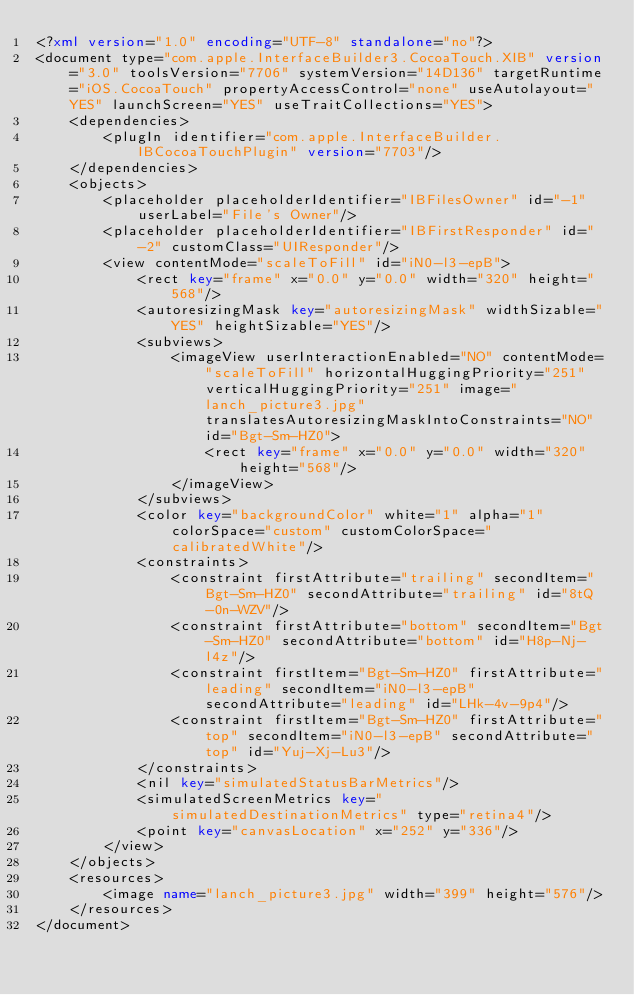<code> <loc_0><loc_0><loc_500><loc_500><_XML_><?xml version="1.0" encoding="UTF-8" standalone="no"?>
<document type="com.apple.InterfaceBuilder3.CocoaTouch.XIB" version="3.0" toolsVersion="7706" systemVersion="14D136" targetRuntime="iOS.CocoaTouch" propertyAccessControl="none" useAutolayout="YES" launchScreen="YES" useTraitCollections="YES">
    <dependencies>
        <plugIn identifier="com.apple.InterfaceBuilder.IBCocoaTouchPlugin" version="7703"/>
    </dependencies>
    <objects>
        <placeholder placeholderIdentifier="IBFilesOwner" id="-1" userLabel="File's Owner"/>
        <placeholder placeholderIdentifier="IBFirstResponder" id="-2" customClass="UIResponder"/>
        <view contentMode="scaleToFill" id="iN0-l3-epB">
            <rect key="frame" x="0.0" y="0.0" width="320" height="568"/>
            <autoresizingMask key="autoresizingMask" widthSizable="YES" heightSizable="YES"/>
            <subviews>
                <imageView userInteractionEnabled="NO" contentMode="scaleToFill" horizontalHuggingPriority="251" verticalHuggingPriority="251" image="lanch_picture3.jpg" translatesAutoresizingMaskIntoConstraints="NO" id="Bgt-Sm-HZ0">
                    <rect key="frame" x="0.0" y="0.0" width="320" height="568"/>
                </imageView>
            </subviews>
            <color key="backgroundColor" white="1" alpha="1" colorSpace="custom" customColorSpace="calibratedWhite"/>
            <constraints>
                <constraint firstAttribute="trailing" secondItem="Bgt-Sm-HZ0" secondAttribute="trailing" id="8tQ-0n-WZV"/>
                <constraint firstAttribute="bottom" secondItem="Bgt-Sm-HZ0" secondAttribute="bottom" id="H8p-Nj-l4z"/>
                <constraint firstItem="Bgt-Sm-HZ0" firstAttribute="leading" secondItem="iN0-l3-epB" secondAttribute="leading" id="LHk-4v-9p4"/>
                <constraint firstItem="Bgt-Sm-HZ0" firstAttribute="top" secondItem="iN0-l3-epB" secondAttribute="top" id="Yuj-Xj-Lu3"/>
            </constraints>
            <nil key="simulatedStatusBarMetrics"/>
            <simulatedScreenMetrics key="simulatedDestinationMetrics" type="retina4"/>
            <point key="canvasLocation" x="252" y="336"/>
        </view>
    </objects>
    <resources>
        <image name="lanch_picture3.jpg" width="399" height="576"/>
    </resources>
</document>
</code> 